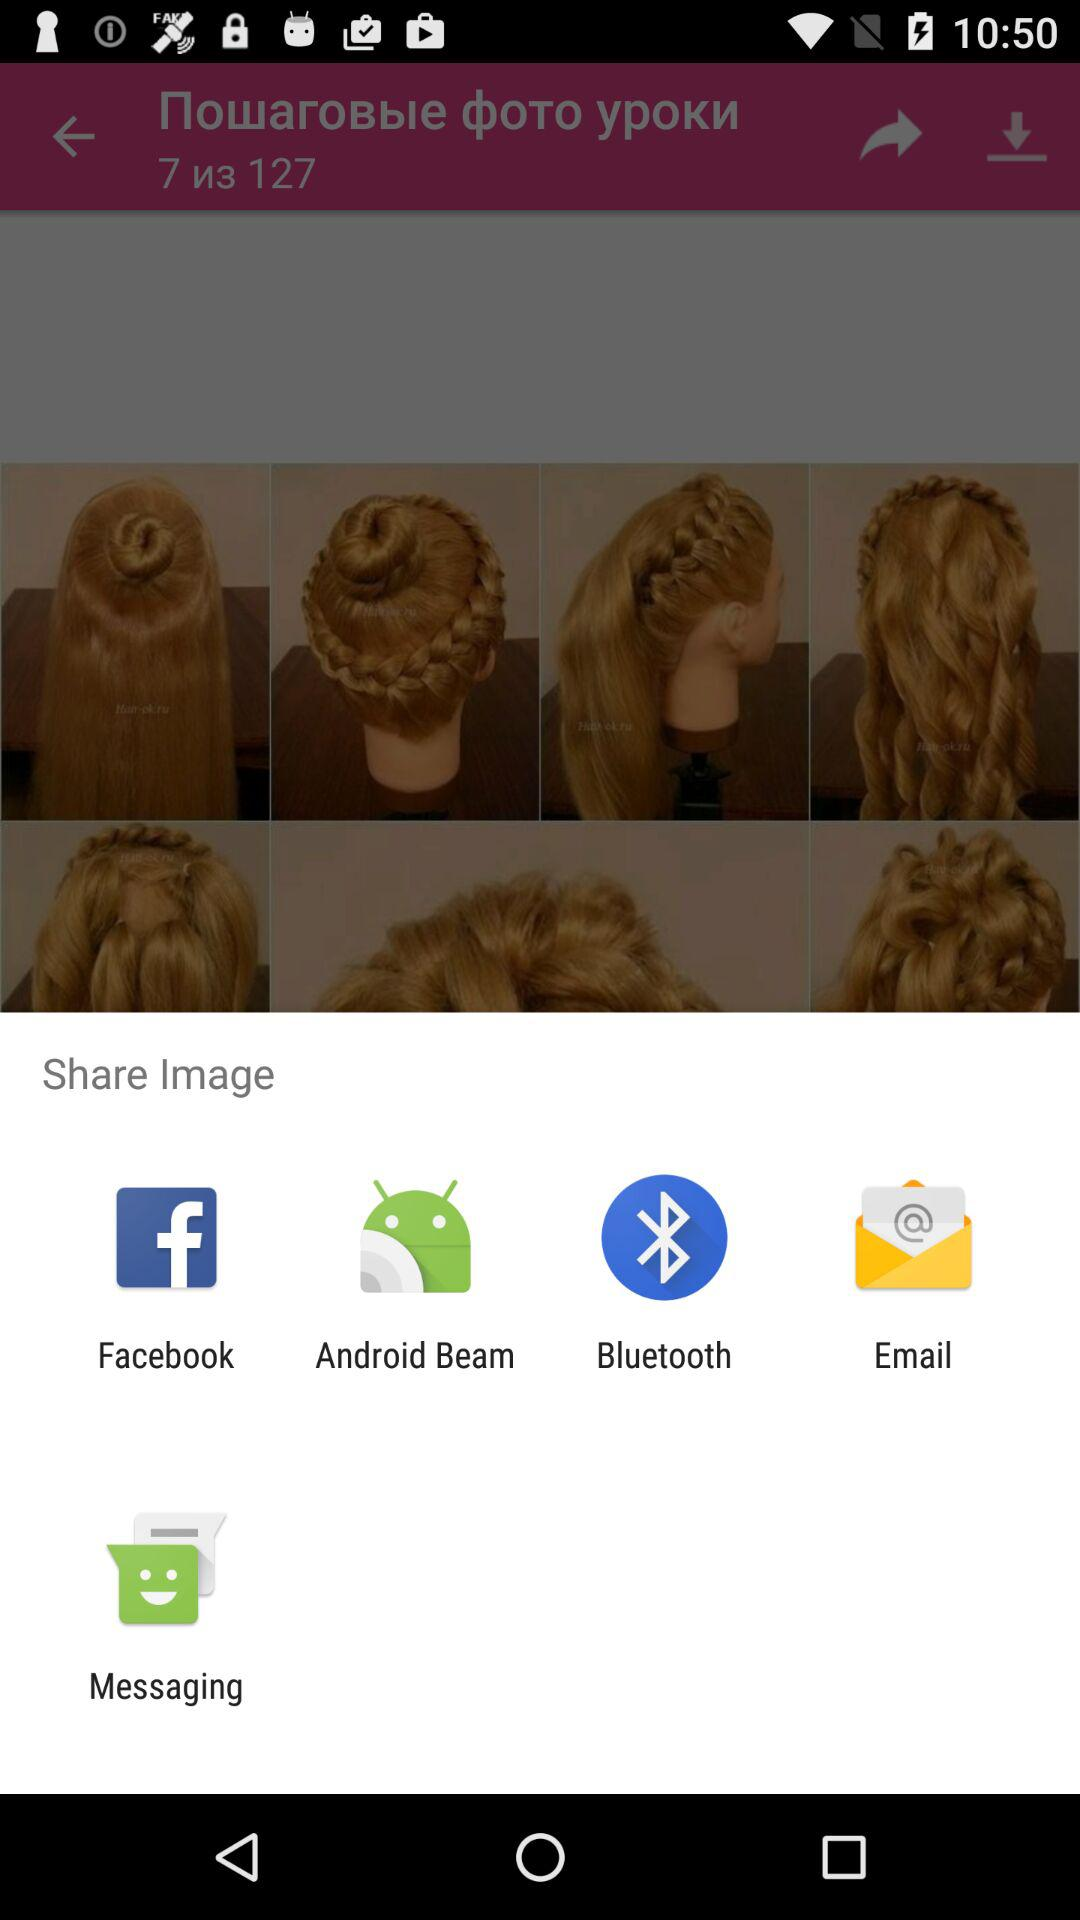Through which app can I share the image? You can share the image through "Facebook", "Android Beam", "Bluetooth", "Email" and "Messaging". 